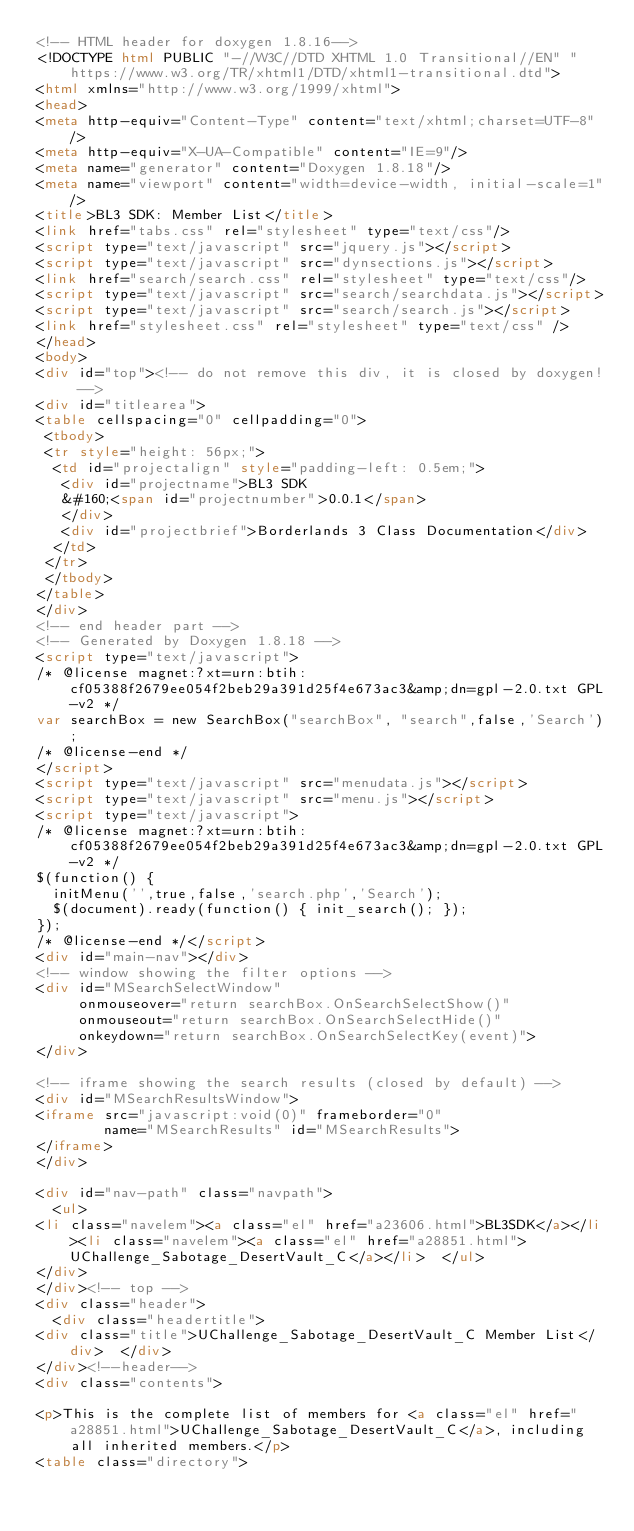Convert code to text. <code><loc_0><loc_0><loc_500><loc_500><_HTML_><!-- HTML header for doxygen 1.8.16-->
<!DOCTYPE html PUBLIC "-//W3C//DTD XHTML 1.0 Transitional//EN" "https://www.w3.org/TR/xhtml1/DTD/xhtml1-transitional.dtd">
<html xmlns="http://www.w3.org/1999/xhtml">
<head>
<meta http-equiv="Content-Type" content="text/xhtml;charset=UTF-8"/>
<meta http-equiv="X-UA-Compatible" content="IE=9"/>
<meta name="generator" content="Doxygen 1.8.18"/>
<meta name="viewport" content="width=device-width, initial-scale=1"/>
<title>BL3 SDK: Member List</title>
<link href="tabs.css" rel="stylesheet" type="text/css"/>
<script type="text/javascript" src="jquery.js"></script>
<script type="text/javascript" src="dynsections.js"></script>
<link href="search/search.css" rel="stylesheet" type="text/css"/>
<script type="text/javascript" src="search/searchdata.js"></script>
<script type="text/javascript" src="search/search.js"></script>
<link href="stylesheet.css" rel="stylesheet" type="text/css" />
</head>
<body>
<div id="top"><!-- do not remove this div, it is closed by doxygen! -->
<div id="titlearea">
<table cellspacing="0" cellpadding="0">
 <tbody>
 <tr style="height: 56px;">
  <td id="projectalign" style="padding-left: 0.5em;">
   <div id="projectname">BL3 SDK
   &#160;<span id="projectnumber">0.0.1</span>
   </div>
   <div id="projectbrief">Borderlands 3 Class Documentation</div>
  </td>
 </tr>
 </tbody>
</table>
</div>
<!-- end header part -->
<!-- Generated by Doxygen 1.8.18 -->
<script type="text/javascript">
/* @license magnet:?xt=urn:btih:cf05388f2679ee054f2beb29a391d25f4e673ac3&amp;dn=gpl-2.0.txt GPL-v2 */
var searchBox = new SearchBox("searchBox", "search",false,'Search');
/* @license-end */
</script>
<script type="text/javascript" src="menudata.js"></script>
<script type="text/javascript" src="menu.js"></script>
<script type="text/javascript">
/* @license magnet:?xt=urn:btih:cf05388f2679ee054f2beb29a391d25f4e673ac3&amp;dn=gpl-2.0.txt GPL-v2 */
$(function() {
  initMenu('',true,false,'search.php','Search');
  $(document).ready(function() { init_search(); });
});
/* @license-end */</script>
<div id="main-nav"></div>
<!-- window showing the filter options -->
<div id="MSearchSelectWindow"
     onmouseover="return searchBox.OnSearchSelectShow()"
     onmouseout="return searchBox.OnSearchSelectHide()"
     onkeydown="return searchBox.OnSearchSelectKey(event)">
</div>

<!-- iframe showing the search results (closed by default) -->
<div id="MSearchResultsWindow">
<iframe src="javascript:void(0)" frameborder="0" 
        name="MSearchResults" id="MSearchResults">
</iframe>
</div>

<div id="nav-path" class="navpath">
  <ul>
<li class="navelem"><a class="el" href="a23606.html">BL3SDK</a></li><li class="navelem"><a class="el" href="a28851.html">UChallenge_Sabotage_DesertVault_C</a></li>  </ul>
</div>
</div><!-- top -->
<div class="header">
  <div class="headertitle">
<div class="title">UChallenge_Sabotage_DesertVault_C Member List</div>  </div>
</div><!--header-->
<div class="contents">

<p>This is the complete list of members for <a class="el" href="a28851.html">UChallenge_Sabotage_DesertVault_C</a>, including all inherited members.</p>
<table class="directory"></code> 